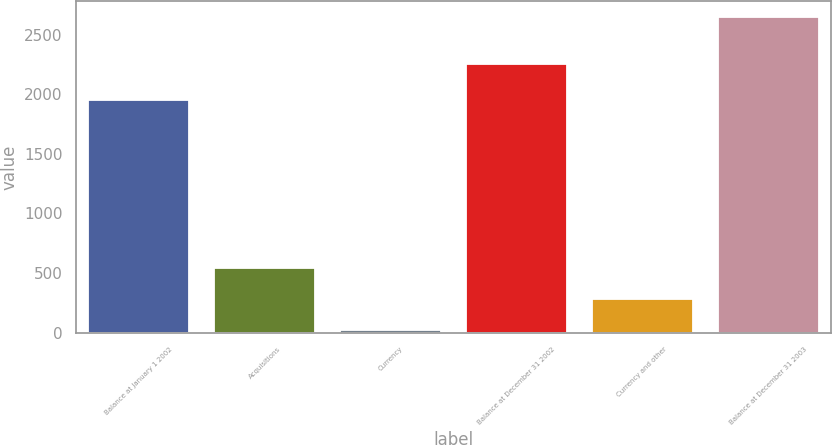Convert chart. <chart><loc_0><loc_0><loc_500><loc_500><bar_chart><fcel>Balance at January 1 2002<fcel>Acquisitions<fcel>Currency<fcel>Balance at December 31 2002<fcel>Currency and other<fcel>Balance at December 31 2003<nl><fcel>1949.2<fcel>545.98<fcel>20.2<fcel>2254.9<fcel>283.09<fcel>2649.1<nl></chart> 